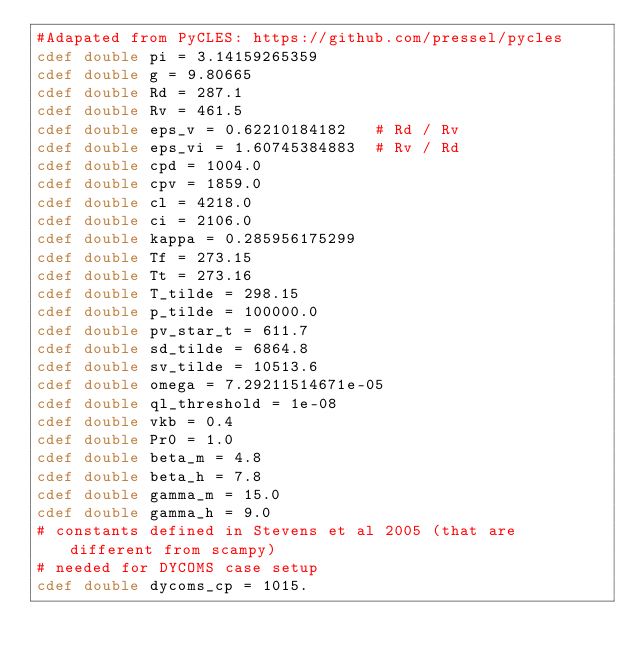Convert code to text. <code><loc_0><loc_0><loc_500><loc_500><_Cython_>#Adapated from PyCLES: https://github.com/pressel/pycles
cdef double pi = 3.14159265359
cdef double g = 9.80665
cdef double Rd = 287.1
cdef double Rv = 461.5
cdef double eps_v = 0.62210184182   # Rd / Rv
cdef double eps_vi = 1.60745384883  # Rv / Rd
cdef double cpd = 1004.0
cdef double cpv = 1859.0
cdef double cl = 4218.0
cdef double ci = 2106.0
cdef double kappa = 0.285956175299
cdef double Tf = 273.15
cdef double Tt = 273.16
cdef double T_tilde = 298.15
cdef double p_tilde = 100000.0
cdef double pv_star_t = 611.7
cdef double sd_tilde = 6864.8
cdef double sv_tilde = 10513.6
cdef double omega = 7.29211514671e-05
cdef double ql_threshold = 1e-08
cdef double vkb = 0.4
cdef double Pr0 = 1.0
cdef double beta_m = 4.8
cdef double beta_h = 7.8
cdef double gamma_m = 15.0
cdef double gamma_h = 9.0
# constants defined in Stevens et al 2005 (that are different from scampy)
# needed for DYCOMS case setup
cdef double dycoms_cp = 1015.</code> 